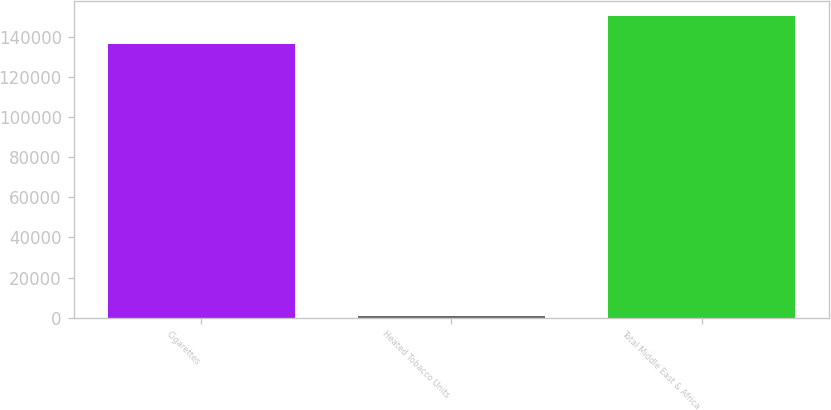Convert chart to OTSL. <chart><loc_0><loc_0><loc_500><loc_500><bar_chart><fcel>Cigarettes<fcel>Heated Tobacco Units<fcel>Total Middle East & Africa<nl><fcel>136759<fcel>907<fcel>150435<nl></chart> 